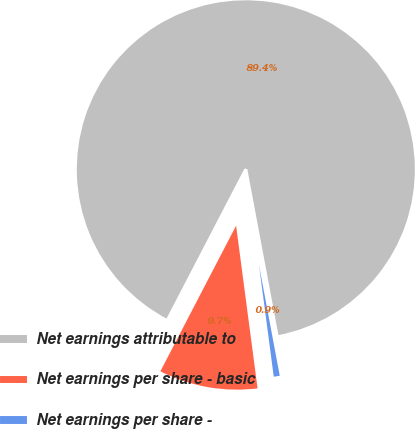<chart> <loc_0><loc_0><loc_500><loc_500><pie_chart><fcel>Net earnings attributable to<fcel>Net earnings per share - basic<fcel>Net earnings per share -<nl><fcel>89.42%<fcel>9.72%<fcel>0.86%<nl></chart> 